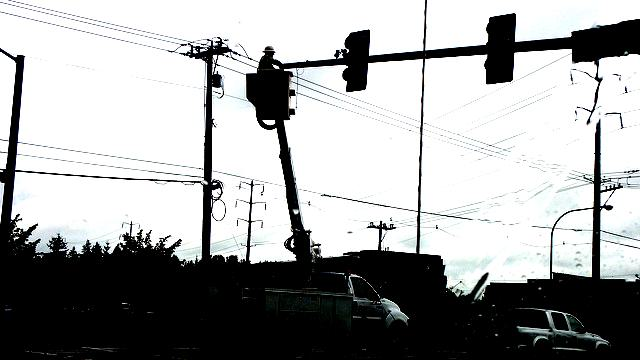What is the visibility of the image content?
A. clear and detailed
B. visible with fine details
C. rough silhouette
D. well-defined The visibility of the image content falls under option C, 'rough silhouette'. The image presents a high-contrast scene with silhouettes of various objects against a brighter background, rendering detailed textures and fine details less discernible. This creates a striking visual effect, but also means that the visibility of specific elements is limited to rough outlines and shapes, absent of clear, fine details. 